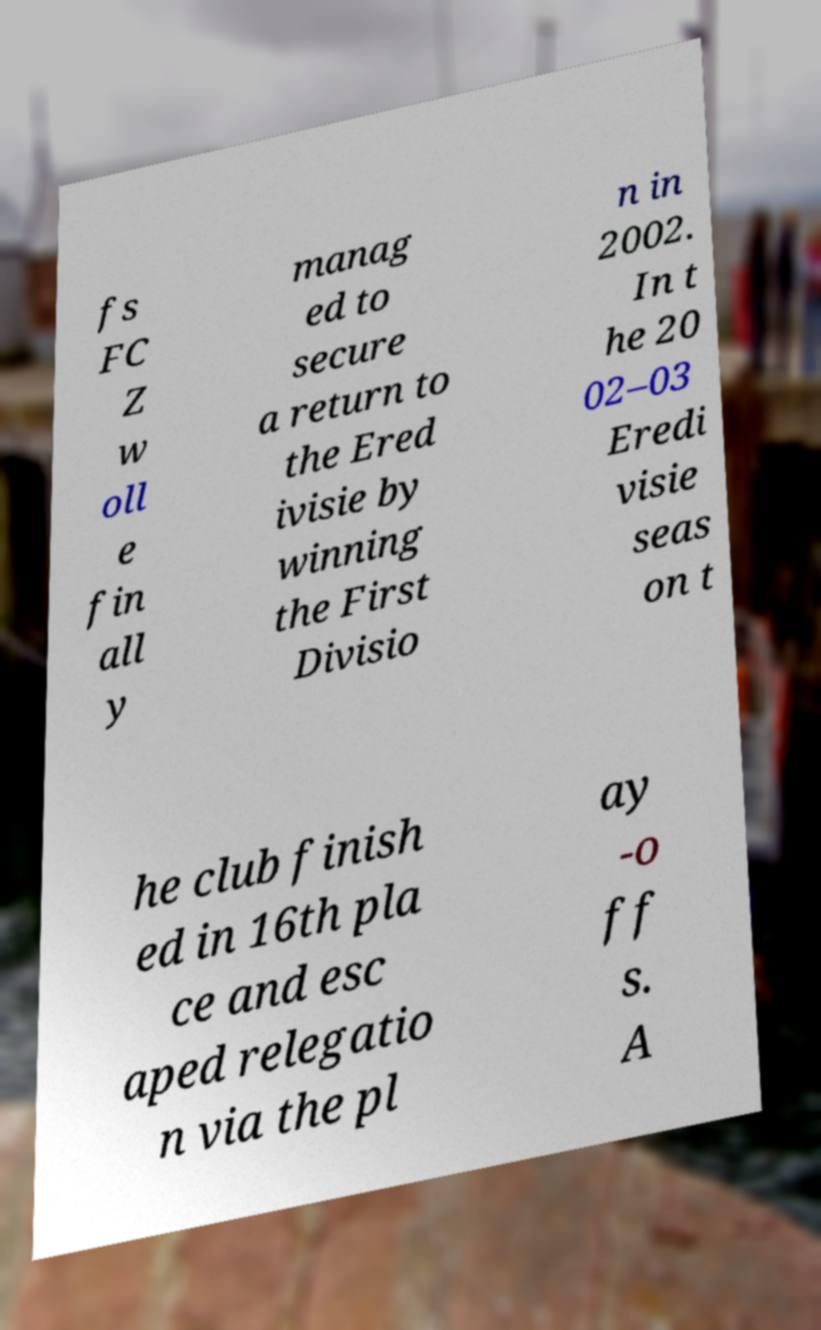Please identify and transcribe the text found in this image. fs FC Z w oll e fin all y manag ed to secure a return to the Ered ivisie by winning the First Divisio n in 2002. In t he 20 02–03 Eredi visie seas on t he club finish ed in 16th pla ce and esc aped relegatio n via the pl ay -o ff s. A 